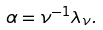Convert formula to latex. <formula><loc_0><loc_0><loc_500><loc_500>\alpha = \nu ^ { - 1 } \lambda _ { \nu } .</formula> 